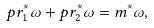<formula> <loc_0><loc_0><loc_500><loc_500>p r _ { 1 } ^ { * } \omega + p r _ { 2 } ^ { * } \omega = m ^ { * } \omega ,</formula> 